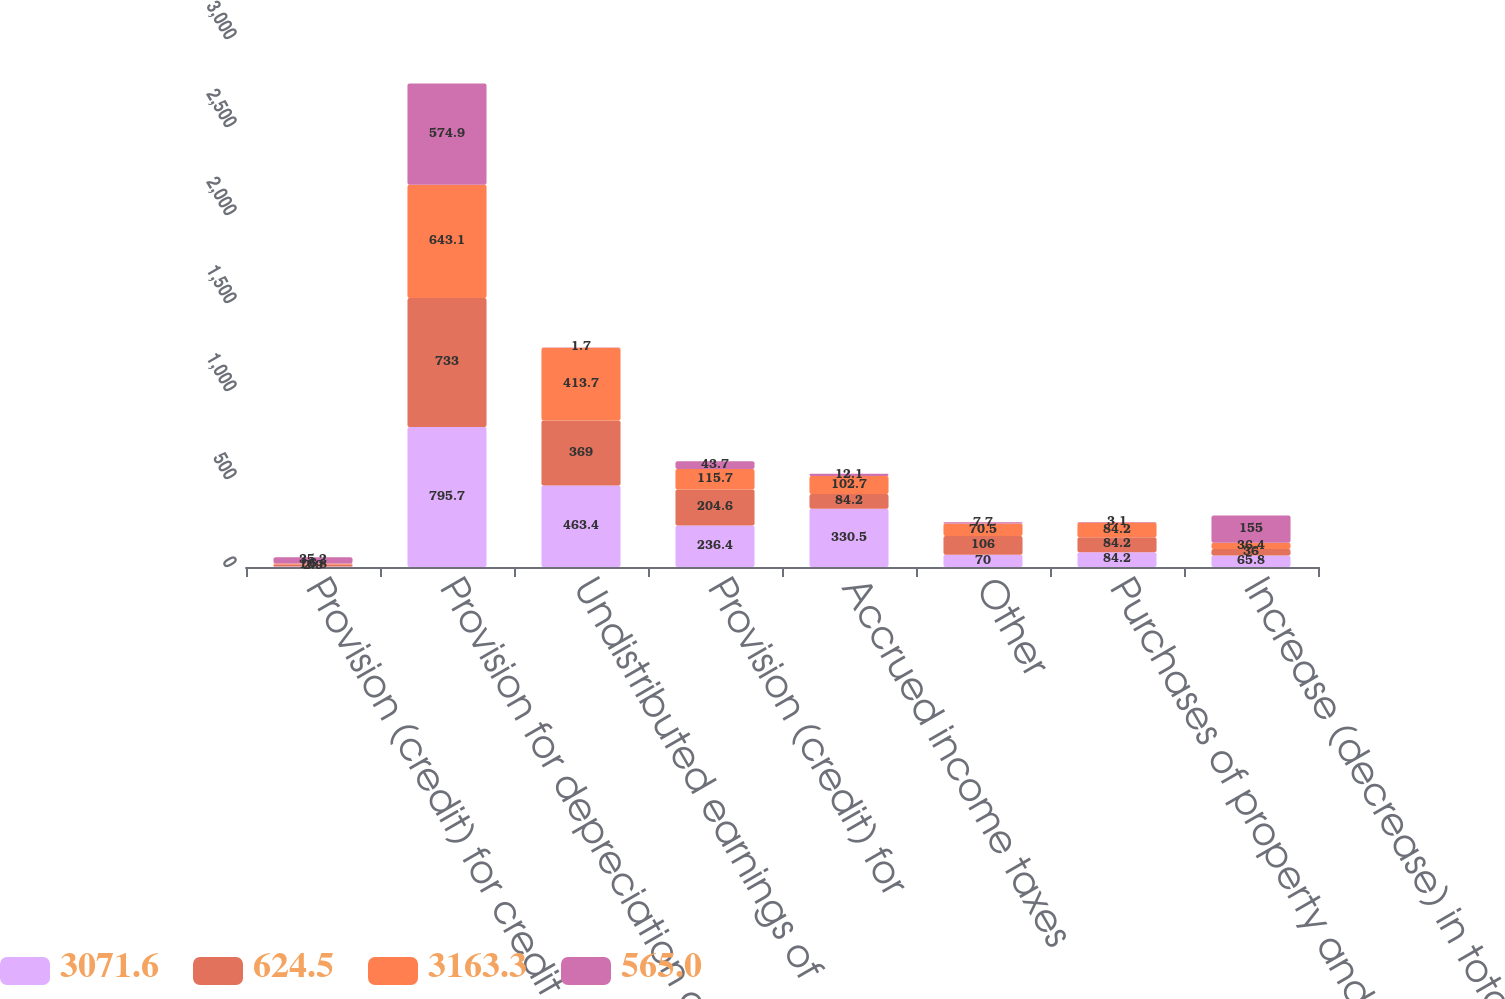Convert chart. <chart><loc_0><loc_0><loc_500><loc_500><stacked_bar_chart><ecel><fcel>Provision (credit) for credit<fcel>Provision for depreciation and<fcel>Undistributed earnings of<fcel>Provision (credit) for<fcel>Accrued income taxes<fcel>Other<fcel>Purchases of property and<fcel>Increase (decrease) in total<nl><fcel>3071.6<fcel>2.9<fcel>795.7<fcel>463.4<fcel>236.4<fcel>330.5<fcel>70<fcel>84.2<fcel>65.8<nl><fcel>624.5<fcel>10.8<fcel>733<fcel>369<fcel>204.6<fcel>84.2<fcel>106<fcel>84.2<fcel>36<nl><fcel>3163.3<fcel>6<fcel>643.1<fcel>413.7<fcel>115.7<fcel>102.7<fcel>70.5<fcel>84.2<fcel>36.4<nl><fcel>565<fcel>35.2<fcel>574.9<fcel>1.7<fcel>43.7<fcel>12.1<fcel>7.7<fcel>3.1<fcel>155<nl></chart> 